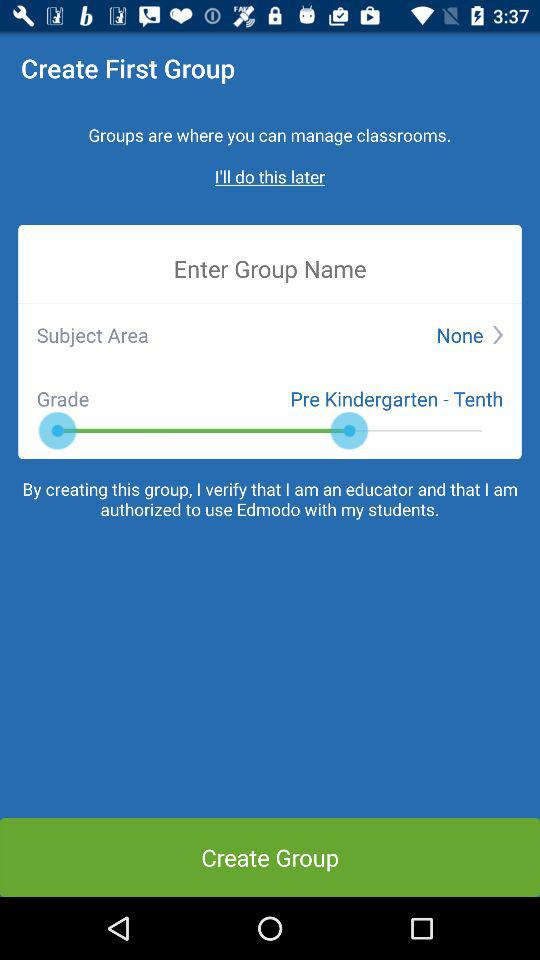Which subject area options are available?
When the provided information is insufficient, respond with <no answer>. <no answer> 